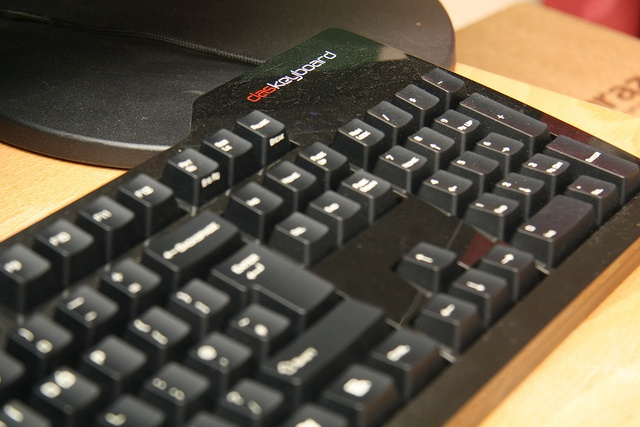Describe the objects in this image and their specific colors. I can see a keyboard in black and gray tones in this image. 